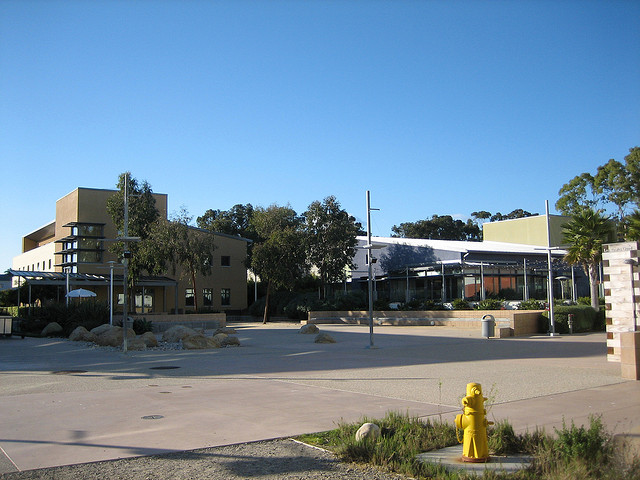What type of building is shown in the background? The building in the background has a modern architectural style with multiple levels, which suggests that it could be an institutional building, possibly a part of a university or corporate campus. 